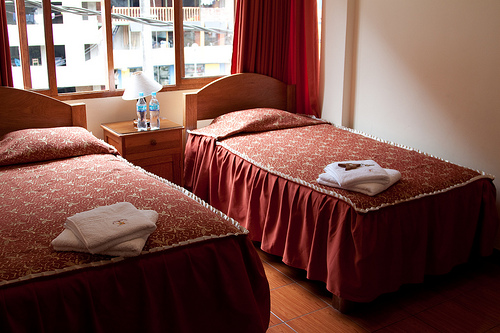Describe the overall atmosphere or style of this room. The room exudes a traditional charm with its wooden bed frames and rich, red bedspreads, matched with heavy curtains. The atmosphere appears cozy and functional, typical of modest hotel accommodations. 